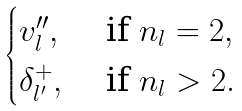Convert formula to latex. <formula><loc_0><loc_0><loc_500><loc_500>\begin{cases} v ^ { \prime \prime } _ { l } , & \text { if } n _ { l } = 2 , \\ \delta _ { l ^ { \prime } } ^ { + } , & \text { if } n _ { l } > 2 . \\ \end{cases}</formula> 